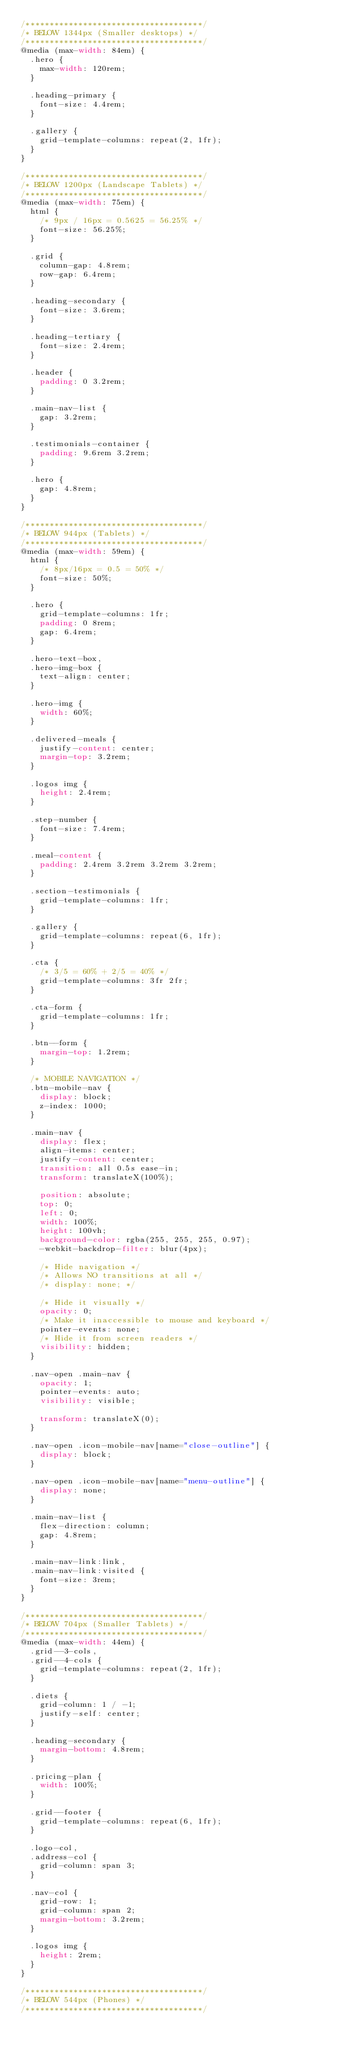Convert code to text. <code><loc_0><loc_0><loc_500><loc_500><_CSS_>/*************************************/
/* BELOW 1344px (Smaller desktops) */
/*************************************/
@media (max-width: 84em) {
  .hero {
    max-width: 120rem;
  }

  .heading-primary {
    font-size: 4.4rem;
  }

  .gallery {
    grid-template-columns: repeat(2, 1fr);
  }
}

/*************************************/
/* BELOW 1200px (Landscape Tablets) */
/*************************************/
@media (max-width: 75em) {
  html {
    /* 9px / 16px = 0.5625 = 56.25% */
    font-size: 56.25%;
  }

  .grid {
    column-gap: 4.8rem;
    row-gap: 6.4rem;
  }

  .heading-secondary {
    font-size: 3.6rem;
  }

  .heading-tertiary {
    font-size: 2.4rem;
  }

  .header {
    padding: 0 3.2rem;
  }

  .main-nav-list {
    gap: 3.2rem;
  }

  .testimonials-container {
    padding: 9.6rem 3.2rem;
  }

  .hero {
    gap: 4.8rem;
  }
}

/*************************************/
/* BELOW 944px (Tablets) */
/*************************************/
@media (max-width: 59em) {
  html {
    /* 8px/16px = 0.5 = 50% */
    font-size: 50%;
  }

  .hero {
    grid-template-columns: 1fr;
    padding: 0 8rem;
    gap: 6.4rem;
  }

  .hero-text-box,
  .hero-img-box {
    text-align: center;
  }

  .hero-img {
    width: 60%;
  }

  .delivered-meals {
    justify-content: center;
    margin-top: 3.2rem;
  }

  .logos img {
    height: 2.4rem;
  }

  .step-number {
    font-size: 7.4rem;
  }

  .meal-content {
    padding: 2.4rem 3.2rem 3.2rem 3.2rem;
  }

  .section-testimonials {
    grid-template-columns: 1fr;
  }

  .gallery {
    grid-template-columns: repeat(6, 1fr);
  }

  .cta {
    /* 3/5 = 60% + 2/5 = 40% */
    grid-template-columns: 3fr 2fr;
  }

  .cta-form {
    grid-template-columns: 1fr;
  }

  .btn--form {
    margin-top: 1.2rem;
  }

  /* MOBILE NAVIGATION */
  .btn-mobile-nav {
    display: block;
    z-index: 1000;
  }

  .main-nav {
    display: flex;
    align-items: center;
    justify-content: center;
    transition: all 0.5s ease-in;
    transform: translateX(100%);

    position: absolute;
    top: 0;
    left: 0;
    width: 100%;
    height: 100vh;
    background-color: rgba(255, 255, 255, 0.97);
    -webkit-backdrop-filter: blur(4px);

    /* Hide navigation */
    /* Allows NO transitions at all */
    /* display: none; */

    /* Hide it visually */
    opacity: 0;
    /* Make it inaccessible to mouse and keyboard */
    pointer-events: none;
    /* Hide it from screen readers */
    visibility: hidden;
  }

  .nav-open .main-nav {
    opacity: 1;
    pointer-events: auto;
    visibility: visible;

    transform: translateX(0);
  }

  .nav-open .icon-mobile-nav[name="close-outline"] {
    display: block;
  }

  .nav-open .icon-mobile-nav[name="menu-outline"] {
    display: none;
  }

  .main-nav-list {
    flex-direction: column;
    gap: 4.8rem;
  }

  .main-nav-link:link,
  .main-nav-link:visited {
    font-size: 3rem;
  }
}

/*************************************/
/* BELOW 704px (Smaller Tablets) */
/*************************************/
@media (max-width: 44em) {
  .grid--3-cols,
  .grid--4-cols {
    grid-template-columns: repeat(2, 1fr);
  }

  .diets {
    grid-column: 1 / -1;
    justify-self: center;
  }

  .heading-secondary {
    margin-bottom: 4.8rem;
  }

  .pricing-plan {
    width: 100%;
  }

  .grid--footer {
    grid-template-columns: repeat(6, 1fr);
  }

  .logo-col,
  .address-col {
    grid-column: span 3;
  }

  .nav-col {
    grid-row: 1;
    grid-column: span 2;
    margin-bottom: 3.2rem;
  }

  .logos img {
    height: 2rem;
  }
}

/*************************************/
/* BELOW 544px (Phones) */
/*************************************/</code> 